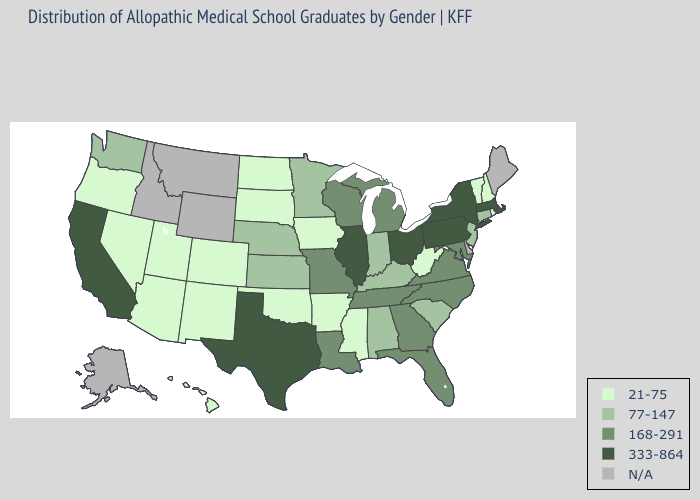What is the value of Hawaii?
Quick response, please. 21-75. What is the highest value in states that border Alabama?
Quick response, please. 168-291. Among the states that border Tennessee , does Missouri have the highest value?
Keep it brief. Yes. Among the states that border Arkansas , does Mississippi have the highest value?
Quick response, please. No. Does Colorado have the highest value in the West?
Short answer required. No. Does Vermont have the lowest value in the USA?
Give a very brief answer. Yes. What is the highest value in the MidWest ?
Be succinct. 333-864. What is the highest value in the West ?
Concise answer only. 333-864. Among the states that border Mississippi , which have the lowest value?
Be succinct. Arkansas. Name the states that have a value in the range 77-147?
Write a very short answer. Alabama, Connecticut, Indiana, Kansas, Kentucky, Minnesota, Nebraska, New Jersey, South Carolina, Washington. Among the states that border New York , which have the highest value?
Concise answer only. Massachusetts, Pennsylvania. Name the states that have a value in the range 77-147?
Be succinct. Alabama, Connecticut, Indiana, Kansas, Kentucky, Minnesota, Nebraska, New Jersey, South Carolina, Washington. What is the value of Georgia?
Short answer required. 168-291. Does Rhode Island have the lowest value in the USA?
Concise answer only. Yes. 